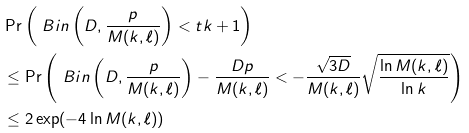Convert formula to latex. <formula><loc_0><loc_0><loc_500><loc_500>& \Pr \left ( \ B i n \left ( D , \frac { p } { M ( k , \ell ) } \right ) < t k + 1 \right ) \\ & \leq \Pr \left ( \ B i n \left ( D , \frac { p } { M ( k , \ell ) } \right ) - \frac { D p } { M ( k , \ell ) } < - \frac { \sqrt { 3 D } } { M ( k , \ell ) } \sqrt { \frac { \ln M ( k , \ell ) } { \ln k } } \right ) \\ & \leq 2 \exp ( - 4 \ln M ( k , \ell ) )</formula> 